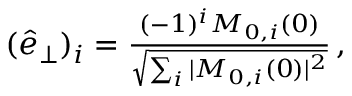<formula> <loc_0><loc_0><loc_500><loc_500>\begin{array} { r } { ( \hat { e } _ { \perp } ) _ { i } = \frac { ( - 1 ) ^ { i } M _ { 0 , i } ( 0 ) } { \sqrt { \sum _ { i } | M _ { 0 , i } ( 0 ) | ^ { 2 } } } \, , } \end{array}</formula> 